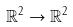Convert formula to latex. <formula><loc_0><loc_0><loc_500><loc_500>\mathbb { R } ^ { 2 } \to \mathbb { R } ^ { 2 }</formula> 